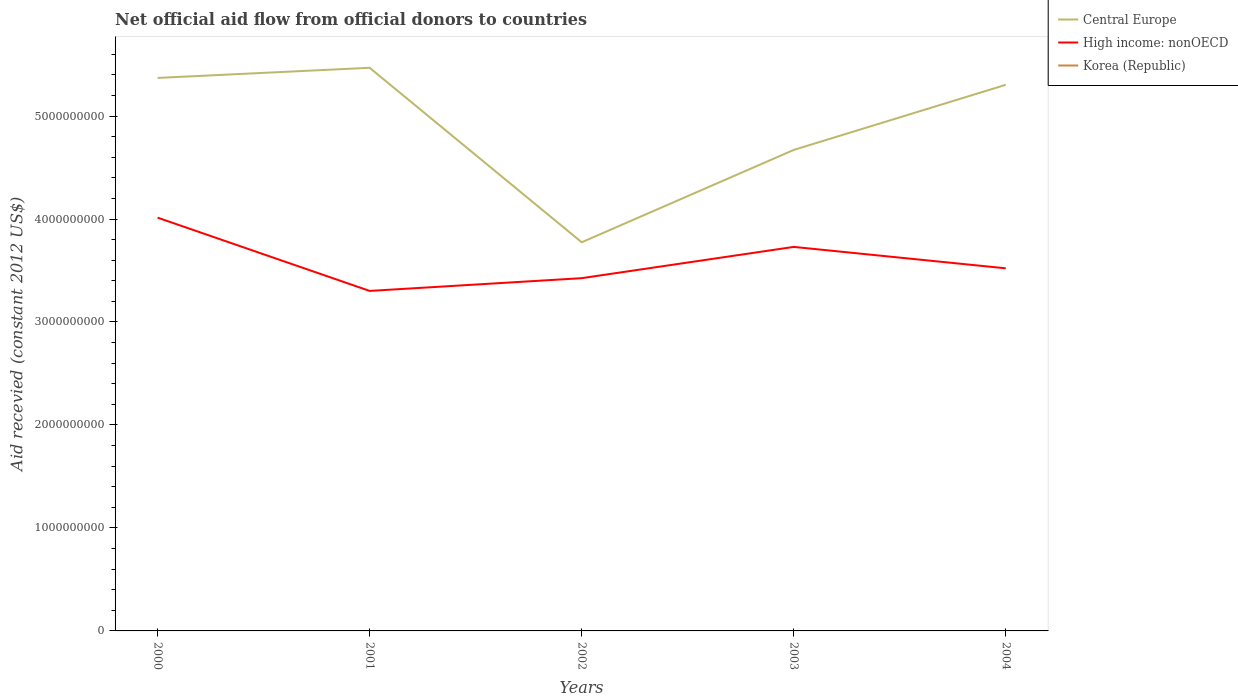How many different coloured lines are there?
Offer a terse response. 2. Does the line corresponding to High income: nonOECD intersect with the line corresponding to Korea (Republic)?
Keep it short and to the point. No. Is the number of lines equal to the number of legend labels?
Your answer should be very brief. No. What is the total total aid received in High income: nonOECD in the graph?
Your response must be concise. -9.56e+07. What is the difference between the highest and the second highest total aid received in Central Europe?
Your response must be concise. 1.69e+09. What is the difference between the highest and the lowest total aid received in Central Europe?
Keep it short and to the point. 3. What is the difference between two consecutive major ticks on the Y-axis?
Offer a very short reply. 1.00e+09. Are the values on the major ticks of Y-axis written in scientific E-notation?
Make the answer very short. No. Does the graph contain grids?
Provide a succinct answer. No. How many legend labels are there?
Provide a short and direct response. 3. What is the title of the graph?
Your response must be concise. Net official aid flow from official donors to countries. Does "Panama" appear as one of the legend labels in the graph?
Give a very brief answer. No. What is the label or title of the Y-axis?
Keep it short and to the point. Aid recevied (constant 2012 US$). What is the Aid recevied (constant 2012 US$) in Central Europe in 2000?
Keep it short and to the point. 5.37e+09. What is the Aid recevied (constant 2012 US$) in High income: nonOECD in 2000?
Give a very brief answer. 4.01e+09. What is the Aid recevied (constant 2012 US$) of Korea (Republic) in 2000?
Ensure brevity in your answer.  0. What is the Aid recevied (constant 2012 US$) of Central Europe in 2001?
Your response must be concise. 5.47e+09. What is the Aid recevied (constant 2012 US$) of High income: nonOECD in 2001?
Give a very brief answer. 3.30e+09. What is the Aid recevied (constant 2012 US$) of Korea (Republic) in 2001?
Keep it short and to the point. 0. What is the Aid recevied (constant 2012 US$) of Central Europe in 2002?
Your answer should be very brief. 3.77e+09. What is the Aid recevied (constant 2012 US$) of High income: nonOECD in 2002?
Give a very brief answer. 3.43e+09. What is the Aid recevied (constant 2012 US$) of Korea (Republic) in 2002?
Provide a succinct answer. 0. What is the Aid recevied (constant 2012 US$) in Central Europe in 2003?
Offer a very short reply. 4.67e+09. What is the Aid recevied (constant 2012 US$) in High income: nonOECD in 2003?
Offer a very short reply. 3.73e+09. What is the Aid recevied (constant 2012 US$) of Korea (Republic) in 2003?
Give a very brief answer. 0. What is the Aid recevied (constant 2012 US$) in Central Europe in 2004?
Provide a succinct answer. 5.30e+09. What is the Aid recevied (constant 2012 US$) of High income: nonOECD in 2004?
Make the answer very short. 3.52e+09. What is the Aid recevied (constant 2012 US$) of Korea (Republic) in 2004?
Your answer should be very brief. 0. Across all years, what is the maximum Aid recevied (constant 2012 US$) in Central Europe?
Your answer should be very brief. 5.47e+09. Across all years, what is the maximum Aid recevied (constant 2012 US$) in High income: nonOECD?
Ensure brevity in your answer.  4.01e+09. Across all years, what is the minimum Aid recevied (constant 2012 US$) in Central Europe?
Keep it short and to the point. 3.77e+09. Across all years, what is the minimum Aid recevied (constant 2012 US$) in High income: nonOECD?
Offer a terse response. 3.30e+09. What is the total Aid recevied (constant 2012 US$) of Central Europe in the graph?
Ensure brevity in your answer.  2.46e+1. What is the total Aid recevied (constant 2012 US$) of High income: nonOECD in the graph?
Offer a very short reply. 1.80e+1. What is the difference between the Aid recevied (constant 2012 US$) of Central Europe in 2000 and that in 2001?
Your answer should be very brief. -9.83e+07. What is the difference between the Aid recevied (constant 2012 US$) of High income: nonOECD in 2000 and that in 2001?
Provide a succinct answer. 7.12e+08. What is the difference between the Aid recevied (constant 2012 US$) in Central Europe in 2000 and that in 2002?
Make the answer very short. 1.60e+09. What is the difference between the Aid recevied (constant 2012 US$) in High income: nonOECD in 2000 and that in 2002?
Offer a terse response. 5.88e+08. What is the difference between the Aid recevied (constant 2012 US$) of Central Europe in 2000 and that in 2003?
Make the answer very short. 6.99e+08. What is the difference between the Aid recevied (constant 2012 US$) in High income: nonOECD in 2000 and that in 2003?
Offer a very short reply. 2.84e+08. What is the difference between the Aid recevied (constant 2012 US$) of Central Europe in 2000 and that in 2004?
Make the answer very short. 6.68e+07. What is the difference between the Aid recevied (constant 2012 US$) of High income: nonOECD in 2000 and that in 2004?
Provide a succinct answer. 4.92e+08. What is the difference between the Aid recevied (constant 2012 US$) in Central Europe in 2001 and that in 2002?
Offer a terse response. 1.69e+09. What is the difference between the Aid recevied (constant 2012 US$) in High income: nonOECD in 2001 and that in 2002?
Your response must be concise. -1.24e+08. What is the difference between the Aid recevied (constant 2012 US$) of Central Europe in 2001 and that in 2003?
Give a very brief answer. 7.98e+08. What is the difference between the Aid recevied (constant 2012 US$) of High income: nonOECD in 2001 and that in 2003?
Your answer should be compact. -4.27e+08. What is the difference between the Aid recevied (constant 2012 US$) of Central Europe in 2001 and that in 2004?
Ensure brevity in your answer.  1.65e+08. What is the difference between the Aid recevied (constant 2012 US$) in High income: nonOECD in 2001 and that in 2004?
Provide a short and direct response. -2.19e+08. What is the difference between the Aid recevied (constant 2012 US$) of Central Europe in 2002 and that in 2003?
Your response must be concise. -8.97e+08. What is the difference between the Aid recevied (constant 2012 US$) in High income: nonOECD in 2002 and that in 2003?
Ensure brevity in your answer.  -3.04e+08. What is the difference between the Aid recevied (constant 2012 US$) in Central Europe in 2002 and that in 2004?
Offer a very short reply. -1.53e+09. What is the difference between the Aid recevied (constant 2012 US$) in High income: nonOECD in 2002 and that in 2004?
Offer a terse response. -9.56e+07. What is the difference between the Aid recevied (constant 2012 US$) of Central Europe in 2003 and that in 2004?
Your response must be concise. -6.32e+08. What is the difference between the Aid recevied (constant 2012 US$) in High income: nonOECD in 2003 and that in 2004?
Your answer should be compact. 2.08e+08. What is the difference between the Aid recevied (constant 2012 US$) in Central Europe in 2000 and the Aid recevied (constant 2012 US$) in High income: nonOECD in 2001?
Make the answer very short. 2.07e+09. What is the difference between the Aid recevied (constant 2012 US$) of Central Europe in 2000 and the Aid recevied (constant 2012 US$) of High income: nonOECD in 2002?
Ensure brevity in your answer.  1.94e+09. What is the difference between the Aid recevied (constant 2012 US$) of Central Europe in 2000 and the Aid recevied (constant 2012 US$) of High income: nonOECD in 2003?
Offer a very short reply. 1.64e+09. What is the difference between the Aid recevied (constant 2012 US$) in Central Europe in 2000 and the Aid recevied (constant 2012 US$) in High income: nonOECD in 2004?
Make the answer very short. 1.85e+09. What is the difference between the Aid recevied (constant 2012 US$) of Central Europe in 2001 and the Aid recevied (constant 2012 US$) of High income: nonOECD in 2002?
Give a very brief answer. 2.04e+09. What is the difference between the Aid recevied (constant 2012 US$) of Central Europe in 2001 and the Aid recevied (constant 2012 US$) of High income: nonOECD in 2003?
Make the answer very short. 1.74e+09. What is the difference between the Aid recevied (constant 2012 US$) in Central Europe in 2001 and the Aid recevied (constant 2012 US$) in High income: nonOECD in 2004?
Keep it short and to the point. 1.95e+09. What is the difference between the Aid recevied (constant 2012 US$) in Central Europe in 2002 and the Aid recevied (constant 2012 US$) in High income: nonOECD in 2003?
Provide a short and direct response. 4.50e+07. What is the difference between the Aid recevied (constant 2012 US$) in Central Europe in 2002 and the Aid recevied (constant 2012 US$) in High income: nonOECD in 2004?
Give a very brief answer. 2.53e+08. What is the difference between the Aid recevied (constant 2012 US$) of Central Europe in 2003 and the Aid recevied (constant 2012 US$) of High income: nonOECD in 2004?
Offer a very short reply. 1.15e+09. What is the average Aid recevied (constant 2012 US$) in Central Europe per year?
Offer a very short reply. 4.92e+09. What is the average Aid recevied (constant 2012 US$) of High income: nonOECD per year?
Make the answer very short. 3.60e+09. In the year 2000, what is the difference between the Aid recevied (constant 2012 US$) of Central Europe and Aid recevied (constant 2012 US$) of High income: nonOECD?
Make the answer very short. 1.36e+09. In the year 2001, what is the difference between the Aid recevied (constant 2012 US$) in Central Europe and Aid recevied (constant 2012 US$) in High income: nonOECD?
Your response must be concise. 2.17e+09. In the year 2002, what is the difference between the Aid recevied (constant 2012 US$) in Central Europe and Aid recevied (constant 2012 US$) in High income: nonOECD?
Offer a terse response. 3.49e+08. In the year 2003, what is the difference between the Aid recevied (constant 2012 US$) of Central Europe and Aid recevied (constant 2012 US$) of High income: nonOECD?
Provide a succinct answer. 9.42e+08. In the year 2004, what is the difference between the Aid recevied (constant 2012 US$) of Central Europe and Aid recevied (constant 2012 US$) of High income: nonOECD?
Your response must be concise. 1.78e+09. What is the ratio of the Aid recevied (constant 2012 US$) in Central Europe in 2000 to that in 2001?
Provide a short and direct response. 0.98. What is the ratio of the Aid recevied (constant 2012 US$) in High income: nonOECD in 2000 to that in 2001?
Offer a very short reply. 1.22. What is the ratio of the Aid recevied (constant 2012 US$) of Central Europe in 2000 to that in 2002?
Your answer should be compact. 1.42. What is the ratio of the Aid recevied (constant 2012 US$) in High income: nonOECD in 2000 to that in 2002?
Your answer should be very brief. 1.17. What is the ratio of the Aid recevied (constant 2012 US$) in Central Europe in 2000 to that in 2003?
Offer a very short reply. 1.15. What is the ratio of the Aid recevied (constant 2012 US$) in High income: nonOECD in 2000 to that in 2003?
Provide a succinct answer. 1.08. What is the ratio of the Aid recevied (constant 2012 US$) in Central Europe in 2000 to that in 2004?
Your answer should be very brief. 1.01. What is the ratio of the Aid recevied (constant 2012 US$) of High income: nonOECD in 2000 to that in 2004?
Your response must be concise. 1.14. What is the ratio of the Aid recevied (constant 2012 US$) of Central Europe in 2001 to that in 2002?
Make the answer very short. 1.45. What is the ratio of the Aid recevied (constant 2012 US$) in High income: nonOECD in 2001 to that in 2002?
Provide a succinct answer. 0.96. What is the ratio of the Aid recevied (constant 2012 US$) of Central Europe in 2001 to that in 2003?
Your answer should be compact. 1.17. What is the ratio of the Aid recevied (constant 2012 US$) of High income: nonOECD in 2001 to that in 2003?
Make the answer very short. 0.89. What is the ratio of the Aid recevied (constant 2012 US$) in Central Europe in 2001 to that in 2004?
Give a very brief answer. 1.03. What is the ratio of the Aid recevied (constant 2012 US$) of High income: nonOECD in 2001 to that in 2004?
Keep it short and to the point. 0.94. What is the ratio of the Aid recevied (constant 2012 US$) in Central Europe in 2002 to that in 2003?
Your answer should be compact. 0.81. What is the ratio of the Aid recevied (constant 2012 US$) of High income: nonOECD in 2002 to that in 2003?
Offer a very short reply. 0.92. What is the ratio of the Aid recevied (constant 2012 US$) in Central Europe in 2002 to that in 2004?
Provide a short and direct response. 0.71. What is the ratio of the Aid recevied (constant 2012 US$) of High income: nonOECD in 2002 to that in 2004?
Provide a short and direct response. 0.97. What is the ratio of the Aid recevied (constant 2012 US$) of Central Europe in 2003 to that in 2004?
Provide a succinct answer. 0.88. What is the ratio of the Aid recevied (constant 2012 US$) of High income: nonOECD in 2003 to that in 2004?
Your response must be concise. 1.06. What is the difference between the highest and the second highest Aid recevied (constant 2012 US$) of Central Europe?
Keep it short and to the point. 9.83e+07. What is the difference between the highest and the second highest Aid recevied (constant 2012 US$) of High income: nonOECD?
Keep it short and to the point. 2.84e+08. What is the difference between the highest and the lowest Aid recevied (constant 2012 US$) in Central Europe?
Your response must be concise. 1.69e+09. What is the difference between the highest and the lowest Aid recevied (constant 2012 US$) in High income: nonOECD?
Your answer should be compact. 7.12e+08. 